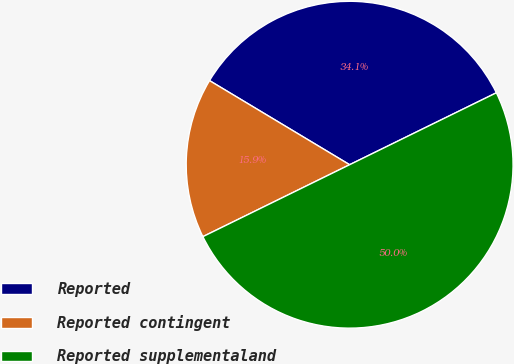Convert chart. <chart><loc_0><loc_0><loc_500><loc_500><pie_chart><fcel>Reported<fcel>Reported contingent<fcel>Reported supplementaland<nl><fcel>34.14%<fcel>15.86%<fcel>50.0%<nl></chart> 